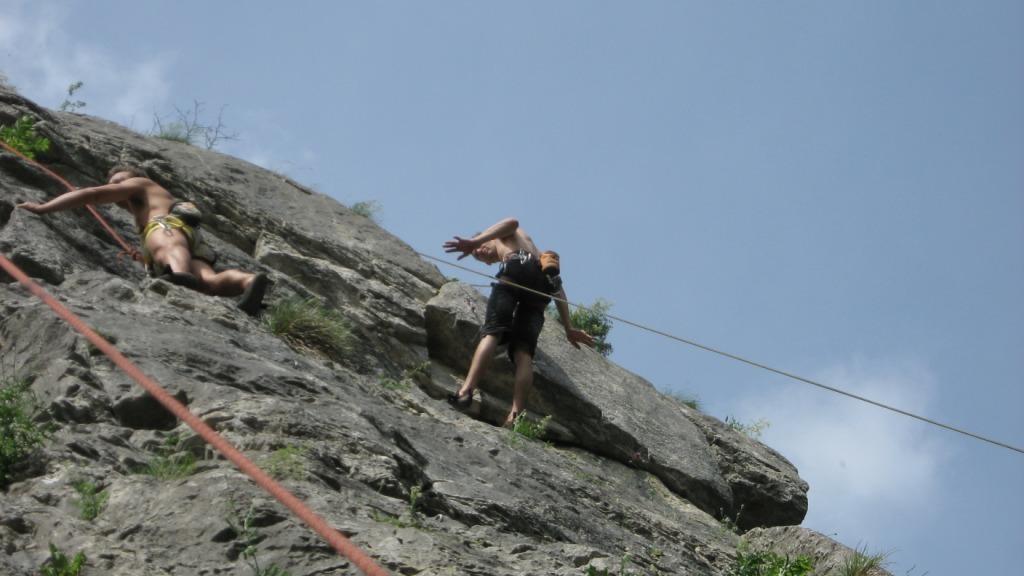Describe this image in one or two sentences. This image consists of two men climbing rocks. There are ropes in red color. At the bottom, there is a rock. At the top, there is a sky. 